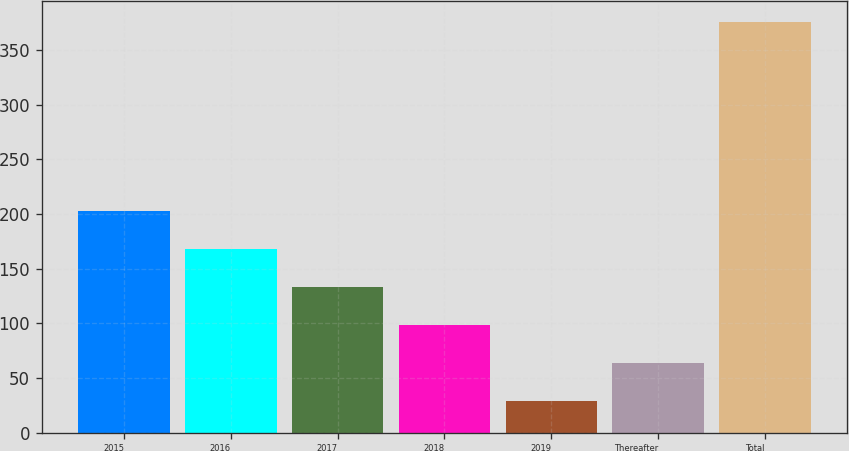Convert chart to OTSL. <chart><loc_0><loc_0><loc_500><loc_500><bar_chart><fcel>2015<fcel>2016<fcel>2017<fcel>2018<fcel>2019<fcel>Thereafter<fcel>Total<nl><fcel>202.5<fcel>167.8<fcel>133.1<fcel>98.4<fcel>29<fcel>63.7<fcel>376<nl></chart> 